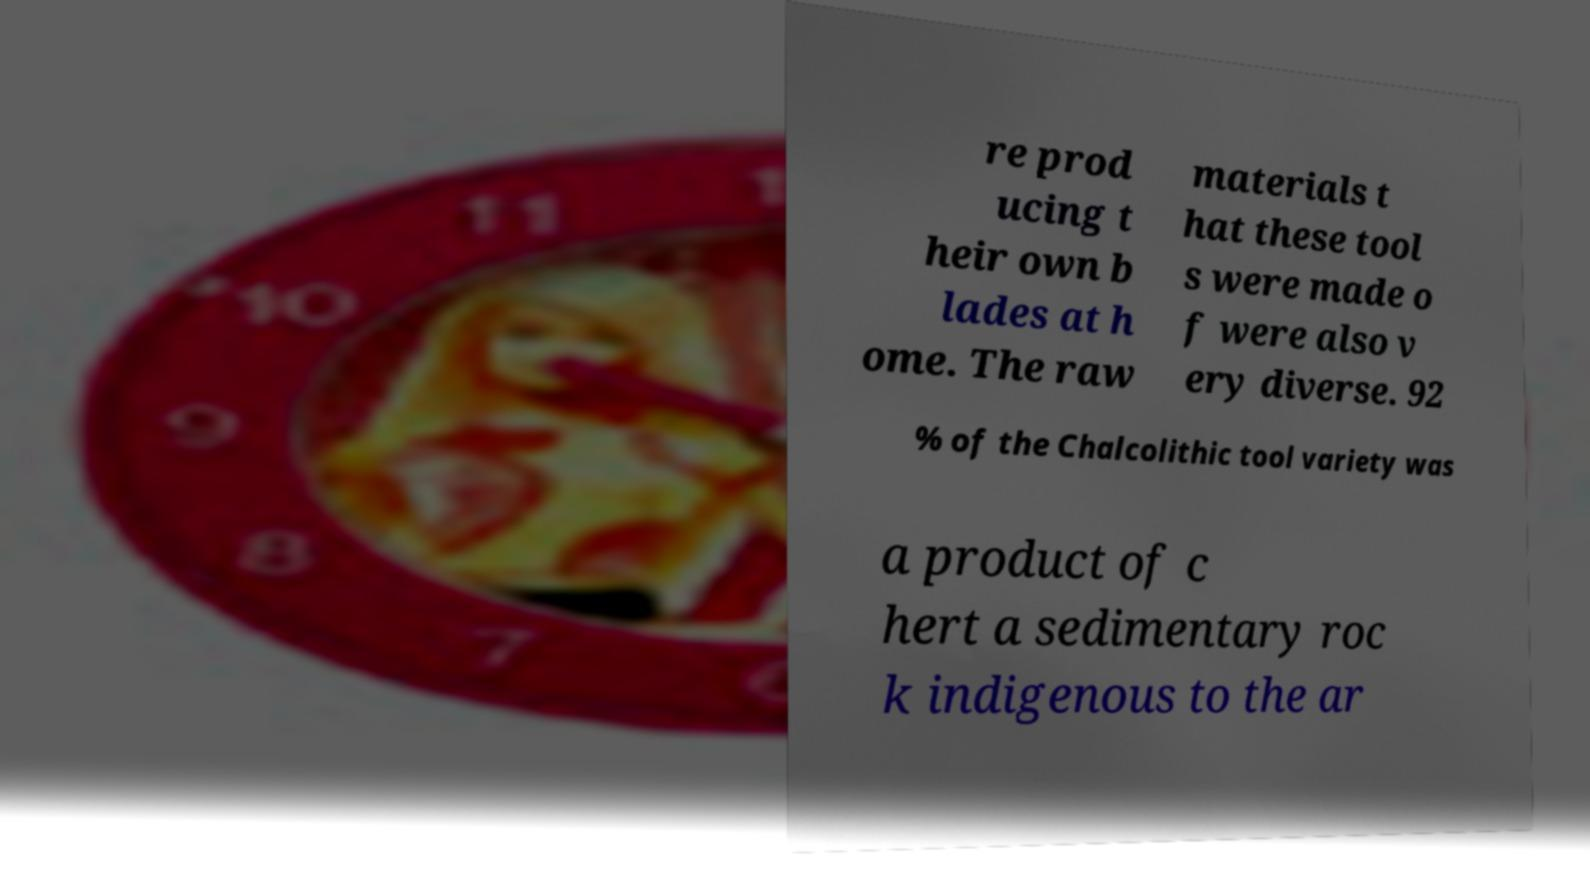Please read and relay the text visible in this image. What does it say? re prod ucing t heir own b lades at h ome. The raw materials t hat these tool s were made o f were also v ery diverse. 92 % of the Chalcolithic tool variety was a product of c hert a sedimentary roc k indigenous to the ar 